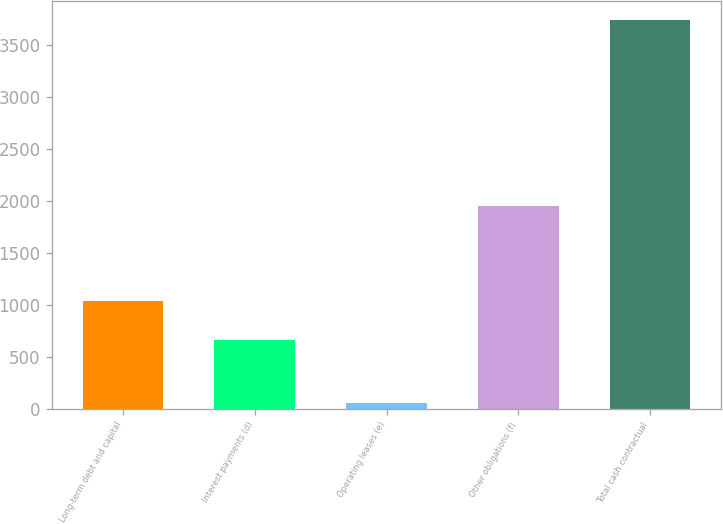Convert chart. <chart><loc_0><loc_0><loc_500><loc_500><bar_chart><fcel>Long-term debt and capital<fcel>Interest payments (d)<fcel>Operating leases (e)<fcel>Other obligations (f)<fcel>Total cash contractual<nl><fcel>1032.8<fcel>664<fcel>51<fcel>1948<fcel>3739<nl></chart> 